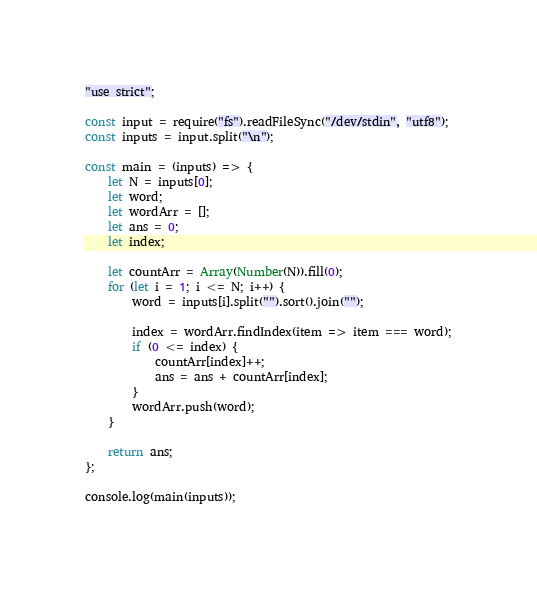<code> <loc_0><loc_0><loc_500><loc_500><_JavaScript_>"use strict";

const input = require("fs").readFileSync("/dev/stdin", "utf8");
const inputs = input.split("\n");

const main = (inputs) => {
    let N = inputs[0];
    let word;
    let wordArr = [];
    let ans = 0;
    let index;

    let countArr = Array(Number(N)).fill(0);
    for (let i = 1; i <= N; i++) {
        word = inputs[i].split("").sort().join("");

        index = wordArr.findIndex(item => item === word);
        if (0 <= index) {
            countArr[index]++;
            ans = ans + countArr[index];
        }
        wordArr.push(word);
    }

    return ans;
};

console.log(main(inputs));</code> 